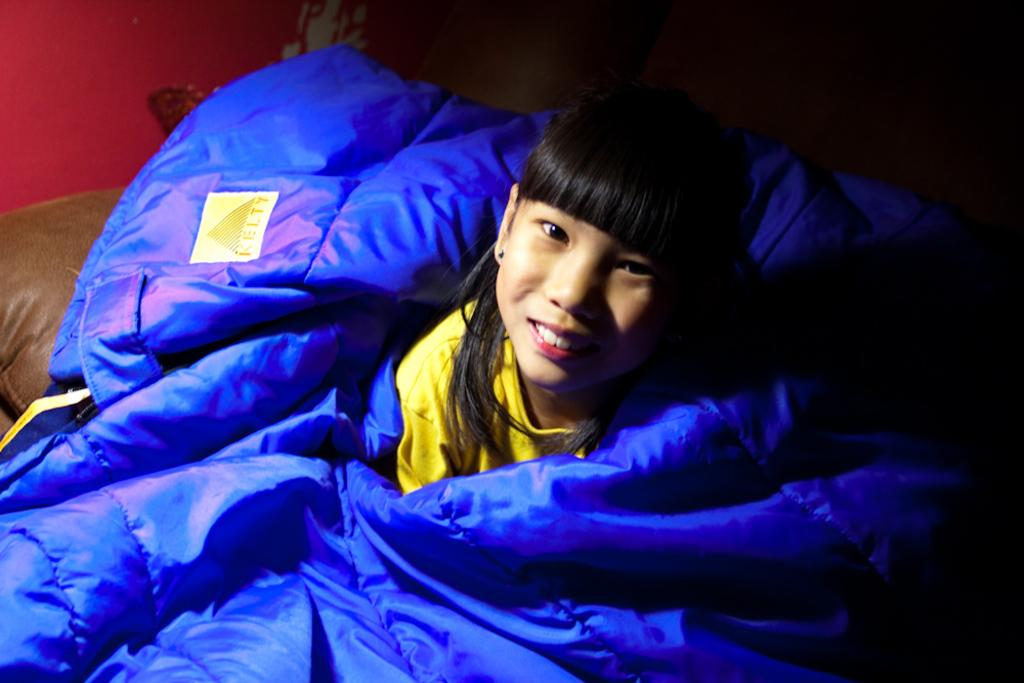Who is the main subject in the image? There is a girl in the image. What is the girl doing or wearing in the image? The girl is covered by a blanket. What can be seen in the background of the image? There is a wall in the background of the image. What type of trees can be seen in the image? There are no trees visible in the image; it features a girl covered by a blanket with a wall in the background. 